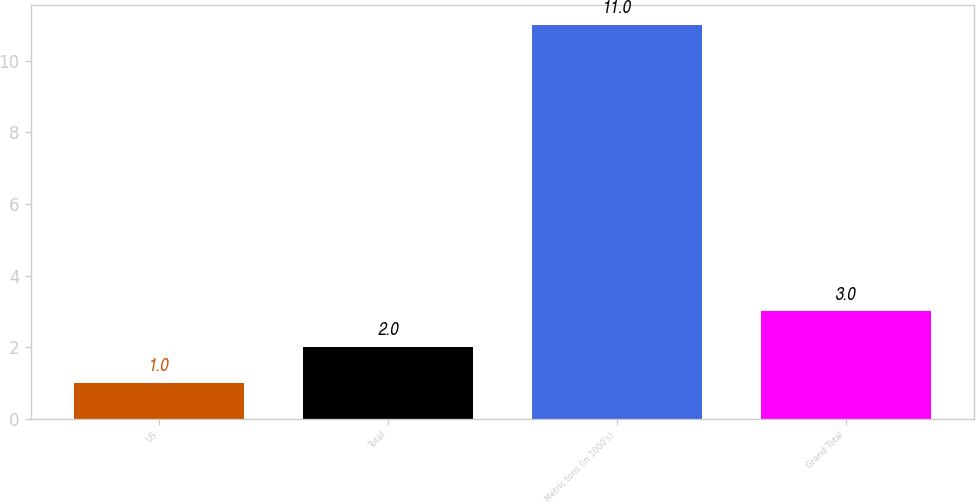Convert chart. <chart><loc_0><loc_0><loc_500><loc_500><bar_chart><fcel>US<fcel>Total<fcel>Metric tons (in 1000's)<fcel>Grand Total<nl><fcel>1<fcel>2<fcel>11<fcel>3<nl></chart> 